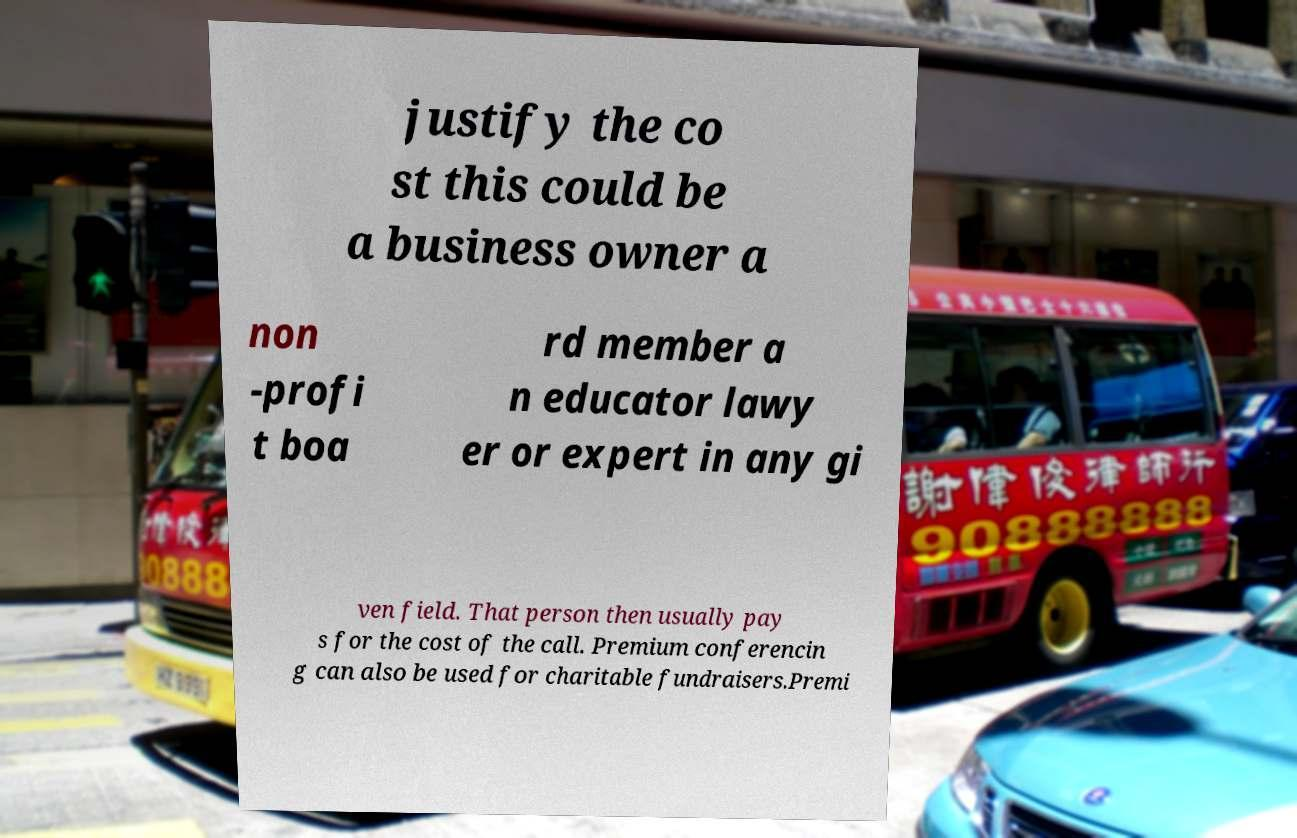What messages or text are displayed in this image? I need them in a readable, typed format. justify the co st this could be a business owner a non -profi t boa rd member a n educator lawy er or expert in any gi ven field. That person then usually pay s for the cost of the call. Premium conferencin g can also be used for charitable fundraisers.Premi 